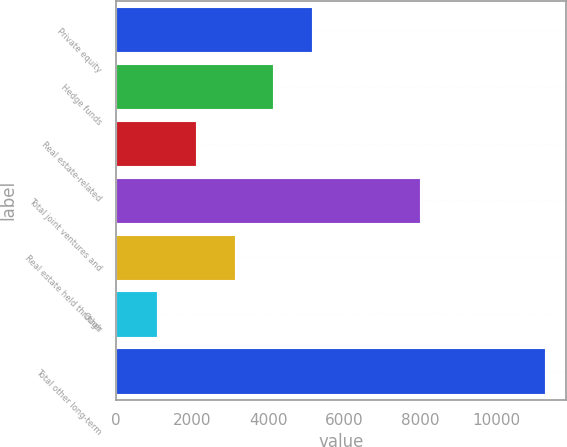<chart> <loc_0><loc_0><loc_500><loc_500><bar_chart><fcel>Private equity<fcel>Hedge funds<fcel>Real estate-related<fcel>Total joint ventures and<fcel>Real estate held through<fcel>Other<fcel>Total other long-term<nl><fcel>5160<fcel>4139.5<fcel>2098.5<fcel>8010<fcel>3119<fcel>1078<fcel>11283<nl></chart> 